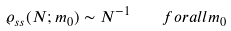<formula> <loc_0><loc_0><loc_500><loc_500>\varrho _ { s s } ( N ; m _ { 0 } ) \sim N ^ { - 1 } \quad f o r a l l m _ { 0 }</formula> 